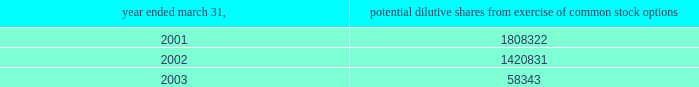( i ) intellectual property the company capitalizes as intellectual property costs incurred , excluding costs associated with company personnel , relating to patenting its technology .
Capitalized costs , the majority of which represent legal costs , reflect the cost of both awarded patents and patents pending .
The company amortizes the cost of these patents on a straight-line basis over a period of seven years .
If the company elects to stop pursuing a particular patent application or determines that a patent application is not likely to be awarded for a particular patent or elects to discontinue payment of required maintenance fees for a particular patent , the company at that time records as expense the net capitalized amount of such patent application or patent .
The company does not capitalize maintenance fees for patents .
( j ) net loss per share basic net loss per share is computed by dividing net loss by the weighted-average number of common shares outstanding during the fiscal year .
Diluted net loss per share is computed by dividing net loss by the weighted-average number of dilutive common shares outstanding during the fiscal year .
Diluted weighted-average shares reflect the dilutive effect , if any , of potential common stock such as options and warrants based on the treasury stock method .
No potential common stock is considered dilutive in periods in which a loss is reported , such as the fiscal years ended march 31 , 2001 , 2002 and 2003 , because all such common equivalent shares would be antidilutive .
The calculation of diluted weighted-average shares outstanding for the years ended march 31 , 2001 , 2002 and 2003 excludes the options to purchase common stock as shown below .
Potential dilutive shares year ended march 31 , from exercise of common stock options .
The calculation of diluted weighted-average shares outstanding excludes unissued shares of common stock associated with outstanding stock options that have exercise prices greater than the average market price of abiomed common stock during the period .
For the fiscal years ending march 31 , 2001 , 2002 and 2003 , the weighted-average number of these potential shares totaled 61661 , 341495 and 2463715 shares , respectively .
The calculation of diluted weighted-average shares outstanding for the years ended march 31 , 2001 , 2002 and 2003 also excludes warrants to purchase 400000 shares of common stock issued in connection with the acquisition of intellectual property ( see note 4 ) .
( k ) cash and cash equivalents the company classifies any marketable security with a maturity date of 90 days or less at the time of purchase as a cash equivalent .
( l ) marketable securities the company classifies any security with a maturity date of greater than 90 days at the time of purchase as marketable securities and classifies marketable securities with a maturity date of greater than one year from the balance sheet date as long-term investments .
Under statement of financial accounting standards ( sfas ) no .
115 , accounting for certain investments in debt and equity securities , securities that the company has the positive intent and ability to hold to maturity are reported at amortized cost and classified as held-to-maturity securities .
The amortized cost and market value of marketable securities were approximately $ 25654000 and $ 25661000 at march 31 , 2002 , and $ 9877000 and $ 9858000 at march 31 , 2003 , respectively .
At march 31 , 2003 , these short-term investments consisted primarily of government securities .
( m ) disclosures about fair value of financial instruments as of march 31 , 2002 and 2003 , the company 2019s financial instruments were comprised of cash and cash equivalents , marketable securities , accounts receivable and accounts payable , the carrying amounts of which approximated fair market value .
( n ) comprehensive income sfas no .
130 , reporting comprehensive income , requires disclosure of all components of comprehensive income and loss on an annual and interim basis .
Comprehensive income and loss is defined as the change in equity of a business enterprise during a period from transactions and other events and circumstances from non-owner sources .
Other than the reported net loss , there were no components of comprehensive income or loss which require disclosure for the years ended march 31 , 2001 , 2002 and 2003 .
Notes to consolidated financial statements ( continued ) march 31 , 2003 page 20 .
What is the difference in amortized cost between 2002 and 2003? 
Computations: (9877000 - 25654000)
Answer: -15777000.0. 